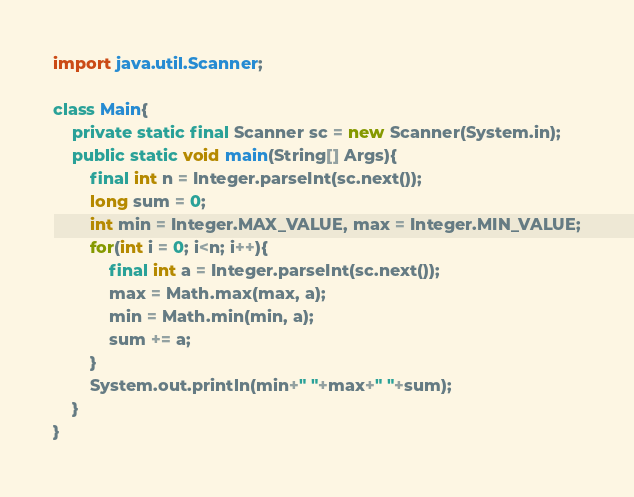<code> <loc_0><loc_0><loc_500><loc_500><_Java_>import java.util.Scanner;

class Main{
    private static final Scanner sc = new Scanner(System.in);
    public static void main(String[] Args){
        final int n = Integer.parseInt(sc.next());
        long sum = 0;
        int min = Integer.MAX_VALUE, max = Integer.MIN_VALUE;
        for(int i = 0; i<n; i++){
            final int a = Integer.parseInt(sc.next());
            max = Math.max(max, a);
            min = Math.min(min, a);
            sum += a;
        }
        System.out.println(min+" "+max+" "+sum);
    }
}</code> 